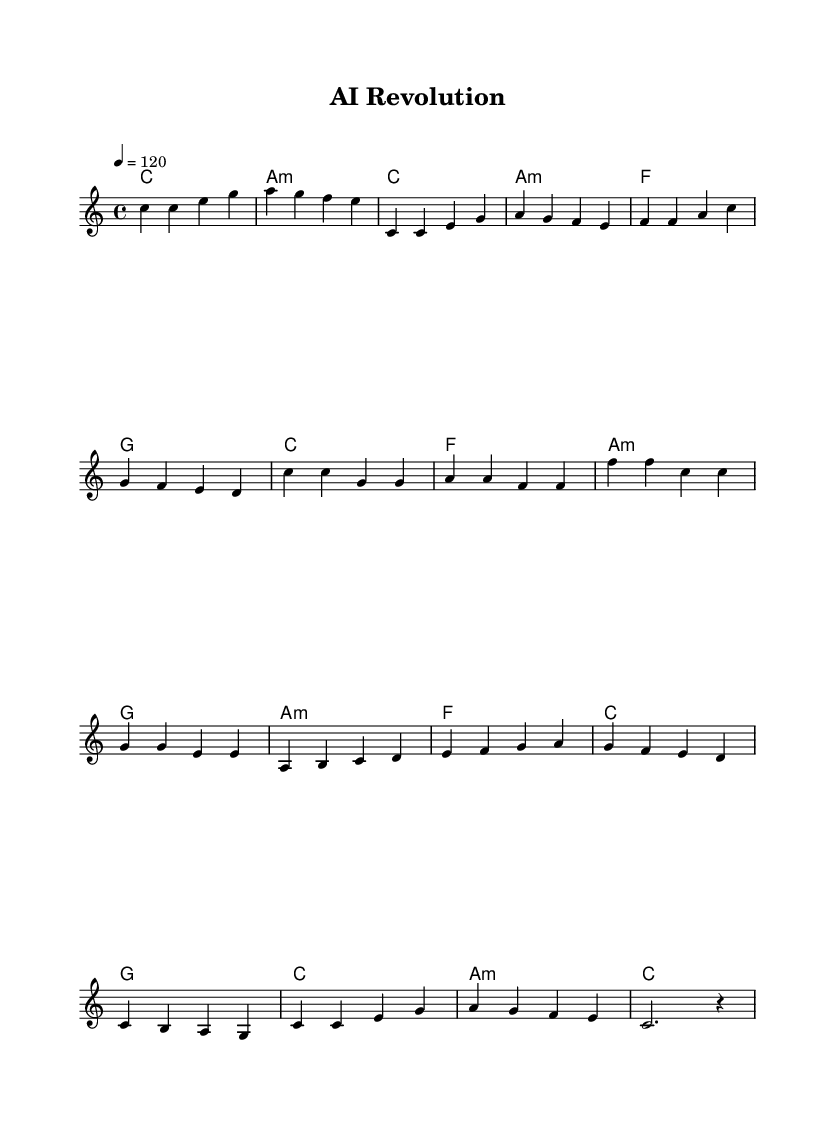What is the key signature of this music? The key signature is C major, which is indicated at the beginning and has no sharps or flats in the staff.
Answer: C major What is the time signature of this music? The time signature is 4/4, shown at the start of the music, indicating there are four beats in each measure and a quarter note gets one beat.
Answer: 4/4 What is the tempo marking for this piece? The tempo marking is 120 beats per minute, specified as "4 = 120" at the start of the score, indicating the speed of the music.
Answer: 120 How many measures are in the chorus section? The chorus section consists of four measures, as seen in the music where it is specifically outlined.
Answer: 4 Which chord appears most frequently in the piece? The chord C major appears most frequently throughout this piece, indicated in the harmonies section across multiple measures.
Answer: C What is the difference in pitch between the lowest note and the highest note in the melody? The lowest note is C (the lowest pitch) and the highest note is A (the highest pitch) in the melody. The difference is an octave, which is identified by counting the notes.
Answer: Octave What is the structure of the song based on the sections? The song structure follows a pattern of Intro, Verse, Chorus, Bridge, and Outro, clearly outlined by the separate sections in the musical notation.
Answer: Intro, Verse, Chorus, Bridge, Outro 